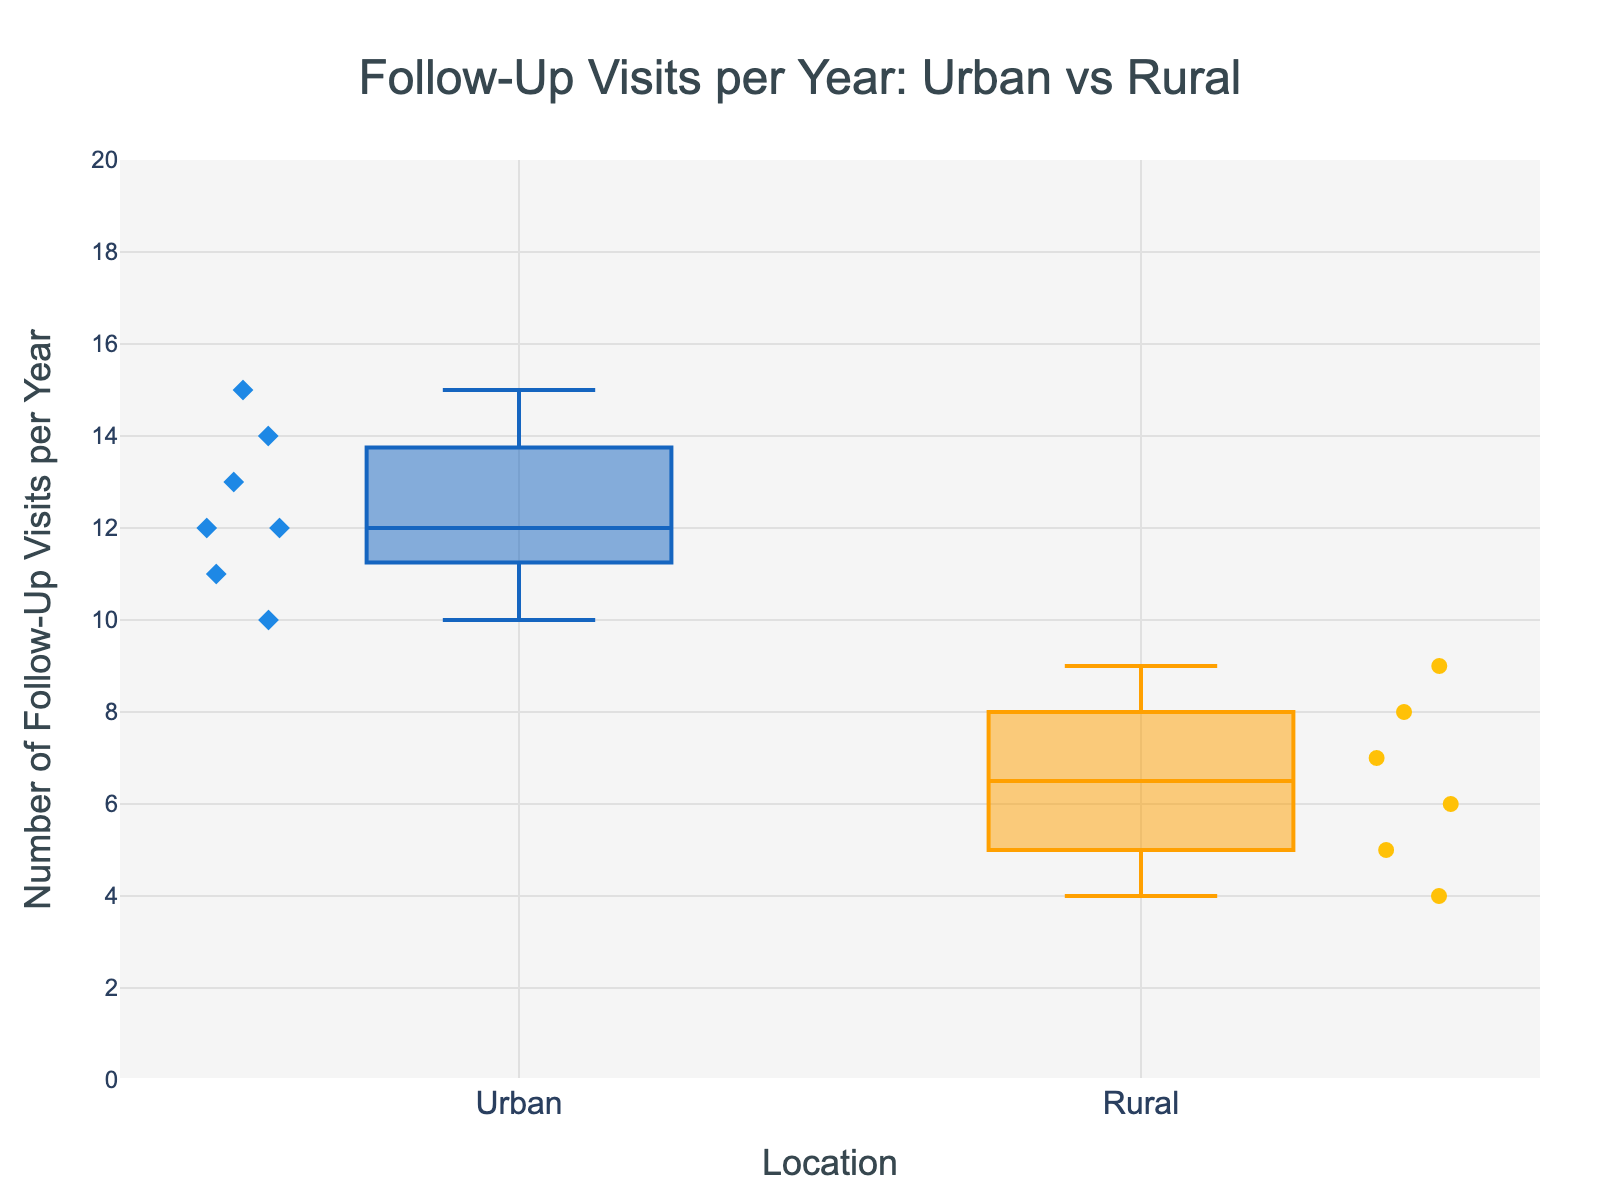What's the median number of follow-up visits per year for urban transplant recipients? The median is the middle value when all data points are ordered. The urban data points are [10, 11, 12, 12, 13, 14, 15]. The median is 12.
Answer: 12 How many data points are there for rural transplant recipients? Count the number of data points in the rural group from the plot. There are 7 data points.
Answer: 7 What is the range of follow-up visits per year for rural transplant recipients? The range is the difference between the maximum and minimum values. For rural: 9 (max) - 4 (min) = 5.
Answer: 5 Which group has the highest individual value of follow-up visits per year? The highest individual value is 15 in the urban group.
Answer: Urban What is the interquartile range (IQR) for urban transplant recipients? The IQR is the range between the first quartile (Q1) and the third quartile (Q3). For urban data: Q1 = 11 and Q3 = 14. IQR = 14 - 11 = 3.
Answer: 3 Which group has the higher median number of follow-up visits per year? Compare the median values: Urban has 12 and Rural has 7.5. Urban has the higher median.
Answer: Urban How many more follow-up visits per year does the median urban recipient have compared to the median rural recipient? Median value for urban = 12, for rural = 7.5. Difference = 12 - 7.5 = 4.5.
Answer: 4.5 What are the minimum and maximum follow-up visits per year for rural transplant recipients? The range for rural data points is from 4 to 9. Therefore, the minimum is 4, and the maximum is 9.
Answer: Minimum: 4, Maximum: 9 What does the box in each boxplot represent? The box represents the interquartile range (IQR), covering from the first quartile (Q1) to the third quartile (Q3), and contains the median line.
Answer: IQR and median line Which group shows more variability in follow-up visits per year? Variability can be assessed by the spread of data. Urban has a more extended range from 10 to 15, compared to rural's range of 4 to 9.
Answer: Urban 